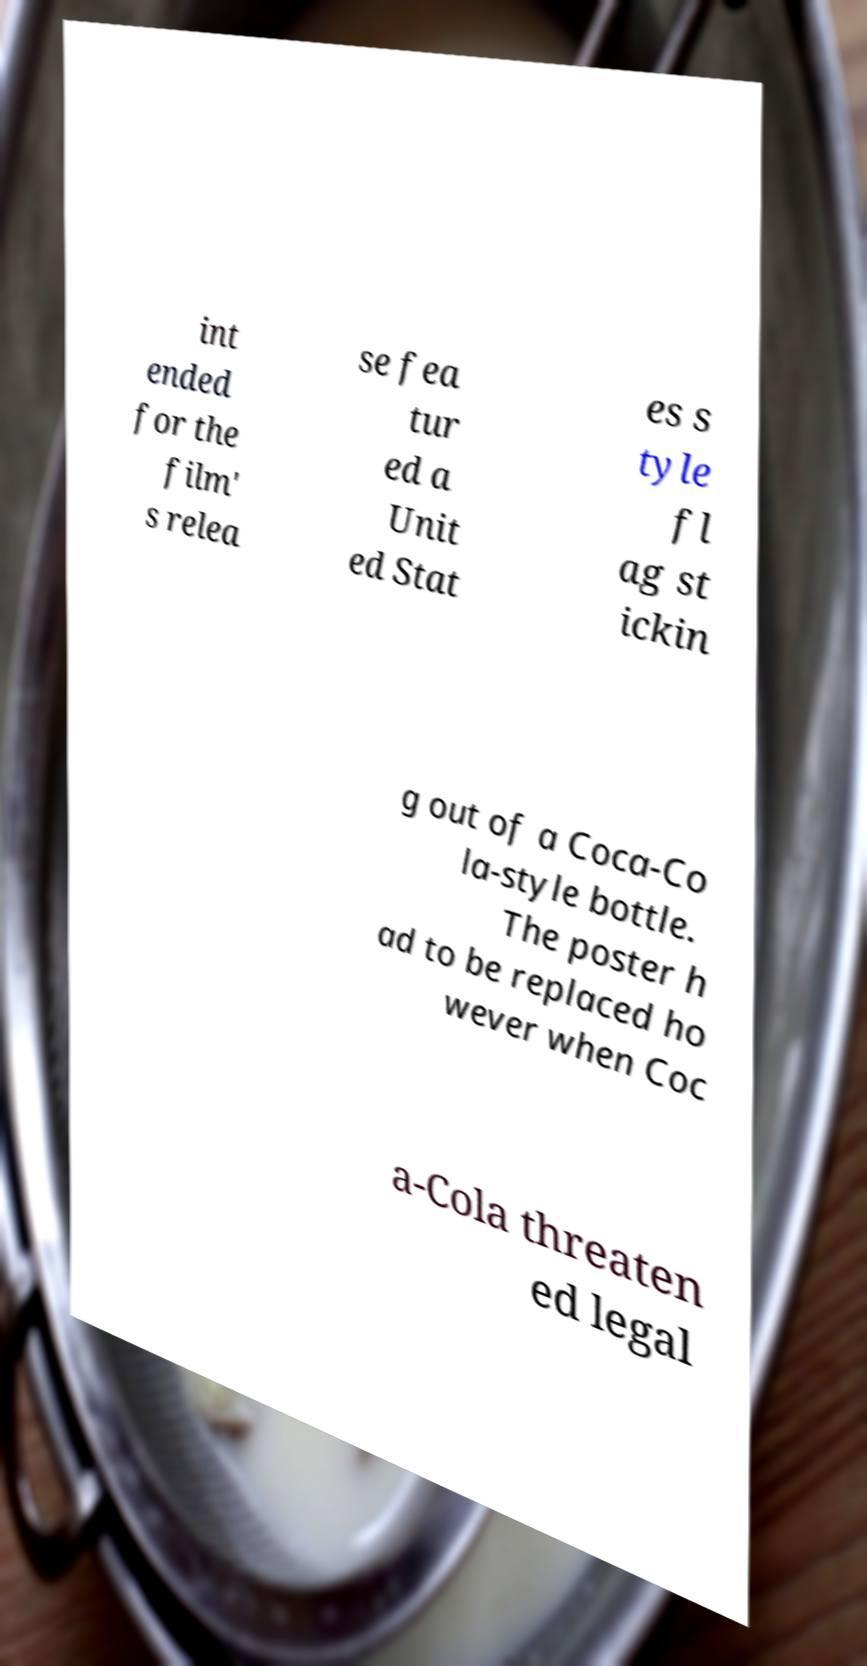What messages or text are displayed in this image? I need them in a readable, typed format. int ended for the film' s relea se fea tur ed a Unit ed Stat es s tyle fl ag st ickin g out of a Coca-Co la-style bottle. The poster h ad to be replaced ho wever when Coc a-Cola threaten ed legal 